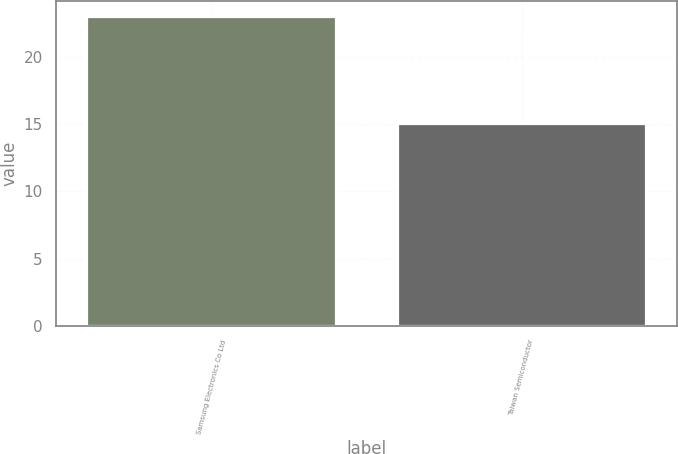Convert chart. <chart><loc_0><loc_0><loc_500><loc_500><bar_chart><fcel>Samsung Electronics Co Ltd<fcel>Taiwan Semiconductor<nl><fcel>23<fcel>15<nl></chart> 